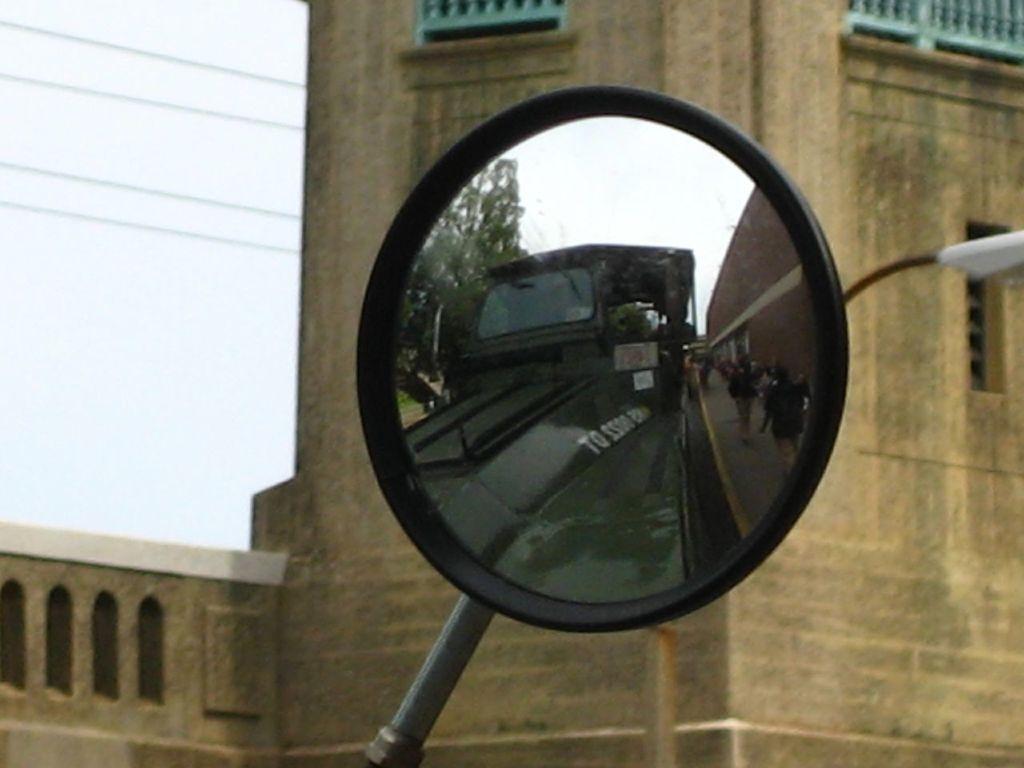Describe this image in one or two sentences. We can see vehicle side mirror, through this side mirror we can see vehicle, people, wall, trees and sky. In the background we can see building, wires, light and sky. 